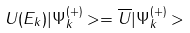<formula> <loc_0><loc_0><loc_500><loc_500>U ( E _ { k } ) | \Psi _ { k } ^ { ( + ) } > = \overline { U } | \Psi _ { k } ^ { ( + ) } ></formula> 